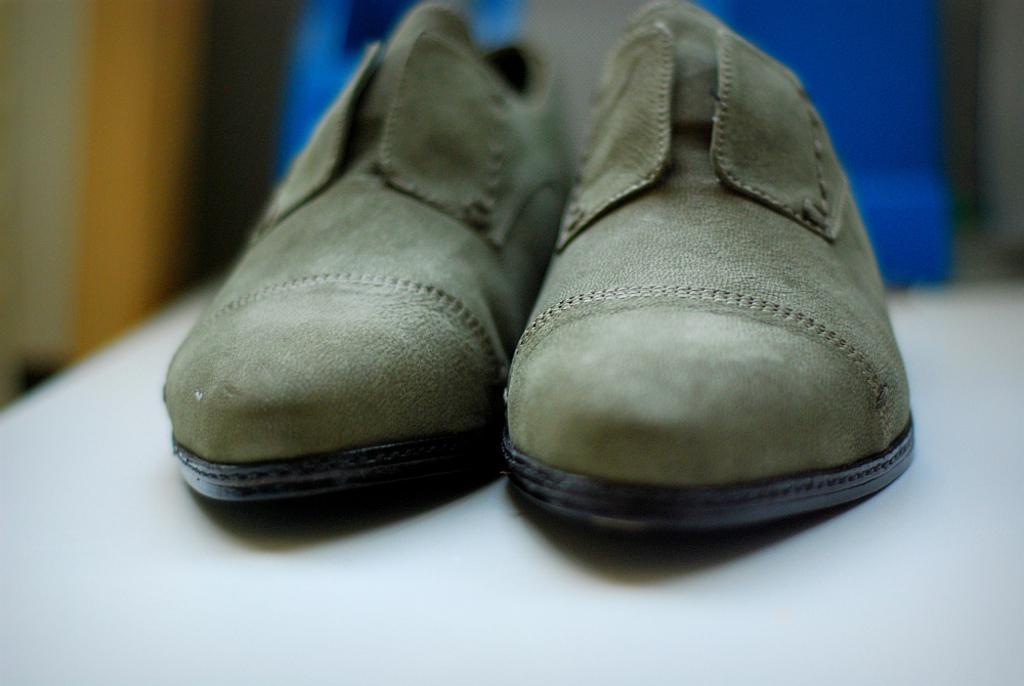Can you describe this image briefly? In this picture we can observe green color shoes placed on the white color table. In the background we can observe blue color object which is blurred. 